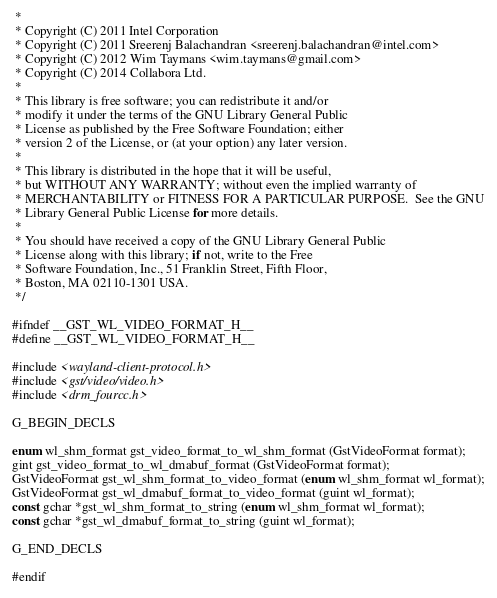<code> <loc_0><loc_0><loc_500><loc_500><_C_> *
 * Copyright (C) 2011 Intel Corporation
 * Copyright (C) 2011 Sreerenj Balachandran <sreerenj.balachandran@intel.com>
 * Copyright (C) 2012 Wim Taymans <wim.taymans@gmail.com>
 * Copyright (C) 2014 Collabora Ltd.
 *
 * This library is free software; you can redistribute it and/or
 * modify it under the terms of the GNU Library General Public
 * License as published by the Free Software Foundation; either
 * version 2 of the License, or (at your option) any later version.
 *
 * This library is distributed in the hope that it will be useful,
 * but WITHOUT ANY WARRANTY; without even the implied warranty of
 * MERCHANTABILITY or FITNESS FOR A PARTICULAR PURPOSE.  See the GNU
 * Library General Public License for more details.
 *
 * You should have received a copy of the GNU Library General Public
 * License along with this library; if not, write to the Free
 * Software Foundation, Inc., 51 Franklin Street, Fifth Floor,
 * Boston, MA 02110-1301 USA.
 */

#ifndef __GST_WL_VIDEO_FORMAT_H__
#define __GST_WL_VIDEO_FORMAT_H__

#include <wayland-client-protocol.h>
#include <gst/video/video.h>
#include <drm_fourcc.h>

G_BEGIN_DECLS

enum wl_shm_format gst_video_format_to_wl_shm_format (GstVideoFormat format);
gint gst_video_format_to_wl_dmabuf_format (GstVideoFormat format);
GstVideoFormat gst_wl_shm_format_to_video_format (enum wl_shm_format wl_format);
GstVideoFormat gst_wl_dmabuf_format_to_video_format (guint wl_format);
const gchar *gst_wl_shm_format_to_string (enum wl_shm_format wl_format);
const gchar *gst_wl_dmabuf_format_to_string (guint wl_format);

G_END_DECLS

#endif
</code> 